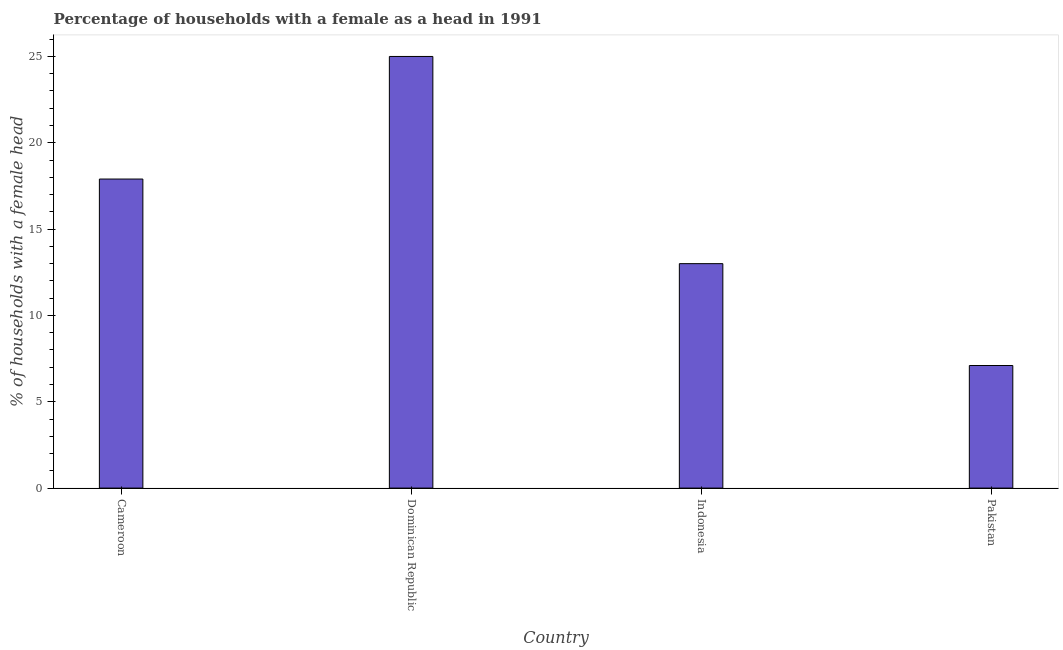Does the graph contain any zero values?
Give a very brief answer. No. Does the graph contain grids?
Give a very brief answer. No. What is the title of the graph?
Provide a short and direct response. Percentage of households with a female as a head in 1991. What is the label or title of the X-axis?
Your answer should be very brief. Country. What is the label or title of the Y-axis?
Provide a short and direct response. % of households with a female head. What is the number of female supervised households in Cameroon?
Make the answer very short. 17.9. Across all countries, what is the maximum number of female supervised households?
Give a very brief answer. 25. In which country was the number of female supervised households maximum?
Your response must be concise. Dominican Republic. In which country was the number of female supervised households minimum?
Your answer should be compact. Pakistan. What is the difference between the number of female supervised households in Dominican Republic and Pakistan?
Give a very brief answer. 17.9. What is the average number of female supervised households per country?
Keep it short and to the point. 15.75. What is the median number of female supervised households?
Make the answer very short. 15.45. In how many countries, is the number of female supervised households greater than 24 %?
Your answer should be compact. 1. What is the ratio of the number of female supervised households in Dominican Republic to that in Indonesia?
Keep it short and to the point. 1.92. What is the difference between the highest and the second highest number of female supervised households?
Make the answer very short. 7.1. What is the difference between the highest and the lowest number of female supervised households?
Your response must be concise. 17.9. In how many countries, is the number of female supervised households greater than the average number of female supervised households taken over all countries?
Provide a short and direct response. 2. Are all the bars in the graph horizontal?
Make the answer very short. No. How many countries are there in the graph?
Give a very brief answer. 4. What is the difference between two consecutive major ticks on the Y-axis?
Keep it short and to the point. 5. Are the values on the major ticks of Y-axis written in scientific E-notation?
Your answer should be very brief. No. What is the % of households with a female head in Cameroon?
Offer a very short reply. 17.9. What is the % of households with a female head of Dominican Republic?
Your answer should be very brief. 25. What is the difference between the % of households with a female head in Cameroon and Indonesia?
Provide a succinct answer. 4.9. What is the difference between the % of households with a female head in Indonesia and Pakistan?
Make the answer very short. 5.9. What is the ratio of the % of households with a female head in Cameroon to that in Dominican Republic?
Keep it short and to the point. 0.72. What is the ratio of the % of households with a female head in Cameroon to that in Indonesia?
Provide a short and direct response. 1.38. What is the ratio of the % of households with a female head in Cameroon to that in Pakistan?
Offer a very short reply. 2.52. What is the ratio of the % of households with a female head in Dominican Republic to that in Indonesia?
Ensure brevity in your answer.  1.92. What is the ratio of the % of households with a female head in Dominican Republic to that in Pakistan?
Your answer should be compact. 3.52. What is the ratio of the % of households with a female head in Indonesia to that in Pakistan?
Provide a succinct answer. 1.83. 